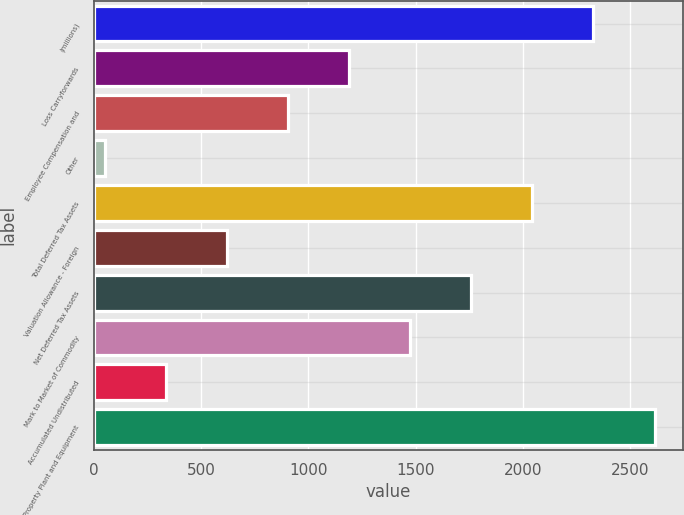<chart> <loc_0><loc_0><loc_500><loc_500><bar_chart><fcel>(millions)<fcel>Loss Carryforwards<fcel>Employee Compensation and<fcel>Other<fcel>Total Deferred Tax Assets<fcel>Valuation Allowance - Foreign<fcel>Net Deferred Tax Assets<fcel>Mark to Market of Commodity<fcel>Accumulated Undistributed<fcel>Property Plant and Equipment<nl><fcel>2328.6<fcel>1189.8<fcel>905.1<fcel>51<fcel>2043.9<fcel>620.4<fcel>1759.2<fcel>1474.5<fcel>335.7<fcel>2613.3<nl></chart> 